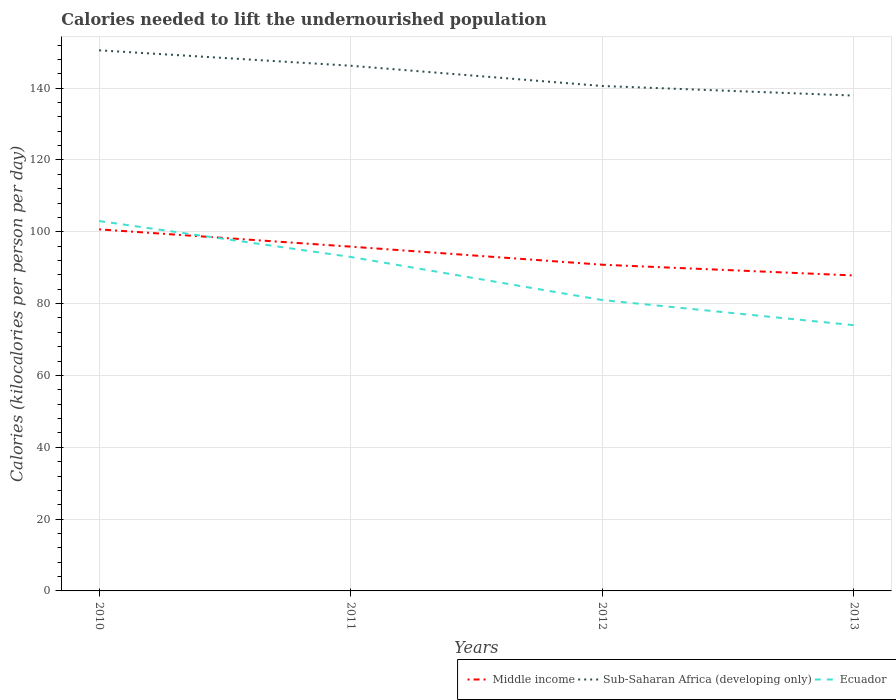How many different coloured lines are there?
Provide a succinct answer. 3. Across all years, what is the maximum total calories needed to lift the undernourished population in Middle income?
Offer a very short reply. 87.84. In which year was the total calories needed to lift the undernourished population in Sub-Saharan Africa (developing only) maximum?
Ensure brevity in your answer.  2013. What is the total total calories needed to lift the undernourished population in Sub-Saharan Africa (developing only) in the graph?
Make the answer very short. 12.6. What is the difference between the highest and the second highest total calories needed to lift the undernourished population in Ecuador?
Your answer should be compact. 29. How many lines are there?
Ensure brevity in your answer.  3. How many years are there in the graph?
Your answer should be compact. 4. Does the graph contain any zero values?
Make the answer very short. No. Does the graph contain grids?
Your answer should be compact. Yes. How many legend labels are there?
Your answer should be very brief. 3. How are the legend labels stacked?
Make the answer very short. Horizontal. What is the title of the graph?
Offer a terse response. Calories needed to lift the undernourished population. Does "Vietnam" appear as one of the legend labels in the graph?
Provide a short and direct response. No. What is the label or title of the X-axis?
Give a very brief answer. Years. What is the label or title of the Y-axis?
Ensure brevity in your answer.  Calories (kilocalories per person per day). What is the Calories (kilocalories per person per day) in Middle income in 2010?
Your answer should be compact. 100.68. What is the Calories (kilocalories per person per day) in Sub-Saharan Africa (developing only) in 2010?
Ensure brevity in your answer.  150.54. What is the Calories (kilocalories per person per day) of Ecuador in 2010?
Make the answer very short. 103. What is the Calories (kilocalories per person per day) in Middle income in 2011?
Keep it short and to the point. 95.87. What is the Calories (kilocalories per person per day) of Sub-Saharan Africa (developing only) in 2011?
Provide a short and direct response. 146.24. What is the Calories (kilocalories per person per day) in Ecuador in 2011?
Give a very brief answer. 93. What is the Calories (kilocalories per person per day) of Middle income in 2012?
Provide a short and direct response. 90.84. What is the Calories (kilocalories per person per day) of Sub-Saharan Africa (developing only) in 2012?
Give a very brief answer. 140.6. What is the Calories (kilocalories per person per day) in Ecuador in 2012?
Offer a very short reply. 81. What is the Calories (kilocalories per person per day) in Middle income in 2013?
Your answer should be very brief. 87.84. What is the Calories (kilocalories per person per day) of Sub-Saharan Africa (developing only) in 2013?
Make the answer very short. 137.94. What is the Calories (kilocalories per person per day) in Ecuador in 2013?
Your response must be concise. 74. Across all years, what is the maximum Calories (kilocalories per person per day) in Middle income?
Ensure brevity in your answer.  100.68. Across all years, what is the maximum Calories (kilocalories per person per day) of Sub-Saharan Africa (developing only)?
Give a very brief answer. 150.54. Across all years, what is the maximum Calories (kilocalories per person per day) in Ecuador?
Ensure brevity in your answer.  103. Across all years, what is the minimum Calories (kilocalories per person per day) in Middle income?
Ensure brevity in your answer.  87.84. Across all years, what is the minimum Calories (kilocalories per person per day) of Sub-Saharan Africa (developing only)?
Make the answer very short. 137.94. What is the total Calories (kilocalories per person per day) of Middle income in the graph?
Provide a short and direct response. 375.23. What is the total Calories (kilocalories per person per day) of Sub-Saharan Africa (developing only) in the graph?
Your answer should be very brief. 575.31. What is the total Calories (kilocalories per person per day) in Ecuador in the graph?
Make the answer very short. 351. What is the difference between the Calories (kilocalories per person per day) of Middle income in 2010 and that in 2011?
Offer a very short reply. 4.81. What is the difference between the Calories (kilocalories per person per day) of Sub-Saharan Africa (developing only) in 2010 and that in 2011?
Offer a very short reply. 4.3. What is the difference between the Calories (kilocalories per person per day) in Ecuador in 2010 and that in 2011?
Provide a short and direct response. 10. What is the difference between the Calories (kilocalories per person per day) of Middle income in 2010 and that in 2012?
Your response must be concise. 9.84. What is the difference between the Calories (kilocalories per person per day) of Sub-Saharan Africa (developing only) in 2010 and that in 2012?
Your answer should be very brief. 9.93. What is the difference between the Calories (kilocalories per person per day) in Middle income in 2010 and that in 2013?
Your answer should be compact. 12.83. What is the difference between the Calories (kilocalories per person per day) in Sub-Saharan Africa (developing only) in 2010 and that in 2013?
Offer a very short reply. 12.6. What is the difference between the Calories (kilocalories per person per day) in Middle income in 2011 and that in 2012?
Provide a short and direct response. 5.03. What is the difference between the Calories (kilocalories per person per day) in Sub-Saharan Africa (developing only) in 2011 and that in 2012?
Offer a very short reply. 5.64. What is the difference between the Calories (kilocalories per person per day) in Ecuador in 2011 and that in 2012?
Ensure brevity in your answer.  12. What is the difference between the Calories (kilocalories per person per day) of Middle income in 2011 and that in 2013?
Your response must be concise. 8.02. What is the difference between the Calories (kilocalories per person per day) in Sub-Saharan Africa (developing only) in 2011 and that in 2013?
Your response must be concise. 8.31. What is the difference between the Calories (kilocalories per person per day) of Middle income in 2012 and that in 2013?
Ensure brevity in your answer.  2.99. What is the difference between the Calories (kilocalories per person per day) in Sub-Saharan Africa (developing only) in 2012 and that in 2013?
Provide a short and direct response. 2.67. What is the difference between the Calories (kilocalories per person per day) of Ecuador in 2012 and that in 2013?
Ensure brevity in your answer.  7. What is the difference between the Calories (kilocalories per person per day) in Middle income in 2010 and the Calories (kilocalories per person per day) in Sub-Saharan Africa (developing only) in 2011?
Provide a short and direct response. -45.56. What is the difference between the Calories (kilocalories per person per day) of Middle income in 2010 and the Calories (kilocalories per person per day) of Ecuador in 2011?
Give a very brief answer. 7.68. What is the difference between the Calories (kilocalories per person per day) of Sub-Saharan Africa (developing only) in 2010 and the Calories (kilocalories per person per day) of Ecuador in 2011?
Keep it short and to the point. 57.54. What is the difference between the Calories (kilocalories per person per day) in Middle income in 2010 and the Calories (kilocalories per person per day) in Sub-Saharan Africa (developing only) in 2012?
Ensure brevity in your answer.  -39.92. What is the difference between the Calories (kilocalories per person per day) of Middle income in 2010 and the Calories (kilocalories per person per day) of Ecuador in 2012?
Provide a succinct answer. 19.68. What is the difference between the Calories (kilocalories per person per day) in Sub-Saharan Africa (developing only) in 2010 and the Calories (kilocalories per person per day) in Ecuador in 2012?
Offer a terse response. 69.54. What is the difference between the Calories (kilocalories per person per day) in Middle income in 2010 and the Calories (kilocalories per person per day) in Sub-Saharan Africa (developing only) in 2013?
Your answer should be very brief. -37.26. What is the difference between the Calories (kilocalories per person per day) of Middle income in 2010 and the Calories (kilocalories per person per day) of Ecuador in 2013?
Keep it short and to the point. 26.68. What is the difference between the Calories (kilocalories per person per day) of Sub-Saharan Africa (developing only) in 2010 and the Calories (kilocalories per person per day) of Ecuador in 2013?
Ensure brevity in your answer.  76.54. What is the difference between the Calories (kilocalories per person per day) of Middle income in 2011 and the Calories (kilocalories per person per day) of Sub-Saharan Africa (developing only) in 2012?
Your answer should be compact. -44.73. What is the difference between the Calories (kilocalories per person per day) in Middle income in 2011 and the Calories (kilocalories per person per day) in Ecuador in 2012?
Your answer should be very brief. 14.87. What is the difference between the Calories (kilocalories per person per day) in Sub-Saharan Africa (developing only) in 2011 and the Calories (kilocalories per person per day) in Ecuador in 2012?
Your answer should be very brief. 65.24. What is the difference between the Calories (kilocalories per person per day) of Middle income in 2011 and the Calories (kilocalories per person per day) of Sub-Saharan Africa (developing only) in 2013?
Offer a very short reply. -42.07. What is the difference between the Calories (kilocalories per person per day) in Middle income in 2011 and the Calories (kilocalories per person per day) in Ecuador in 2013?
Make the answer very short. 21.87. What is the difference between the Calories (kilocalories per person per day) in Sub-Saharan Africa (developing only) in 2011 and the Calories (kilocalories per person per day) in Ecuador in 2013?
Ensure brevity in your answer.  72.24. What is the difference between the Calories (kilocalories per person per day) in Middle income in 2012 and the Calories (kilocalories per person per day) in Sub-Saharan Africa (developing only) in 2013?
Your response must be concise. -47.1. What is the difference between the Calories (kilocalories per person per day) in Middle income in 2012 and the Calories (kilocalories per person per day) in Ecuador in 2013?
Ensure brevity in your answer.  16.84. What is the difference between the Calories (kilocalories per person per day) in Sub-Saharan Africa (developing only) in 2012 and the Calories (kilocalories per person per day) in Ecuador in 2013?
Keep it short and to the point. 66.6. What is the average Calories (kilocalories per person per day) in Middle income per year?
Keep it short and to the point. 93.81. What is the average Calories (kilocalories per person per day) of Sub-Saharan Africa (developing only) per year?
Make the answer very short. 143.83. What is the average Calories (kilocalories per person per day) in Ecuador per year?
Give a very brief answer. 87.75. In the year 2010, what is the difference between the Calories (kilocalories per person per day) of Middle income and Calories (kilocalories per person per day) of Sub-Saharan Africa (developing only)?
Give a very brief answer. -49.86. In the year 2010, what is the difference between the Calories (kilocalories per person per day) of Middle income and Calories (kilocalories per person per day) of Ecuador?
Ensure brevity in your answer.  -2.32. In the year 2010, what is the difference between the Calories (kilocalories per person per day) of Sub-Saharan Africa (developing only) and Calories (kilocalories per person per day) of Ecuador?
Your answer should be very brief. 47.54. In the year 2011, what is the difference between the Calories (kilocalories per person per day) of Middle income and Calories (kilocalories per person per day) of Sub-Saharan Africa (developing only)?
Offer a terse response. -50.37. In the year 2011, what is the difference between the Calories (kilocalories per person per day) of Middle income and Calories (kilocalories per person per day) of Ecuador?
Your answer should be compact. 2.87. In the year 2011, what is the difference between the Calories (kilocalories per person per day) of Sub-Saharan Africa (developing only) and Calories (kilocalories per person per day) of Ecuador?
Provide a succinct answer. 53.24. In the year 2012, what is the difference between the Calories (kilocalories per person per day) of Middle income and Calories (kilocalories per person per day) of Sub-Saharan Africa (developing only)?
Provide a succinct answer. -49.77. In the year 2012, what is the difference between the Calories (kilocalories per person per day) of Middle income and Calories (kilocalories per person per day) of Ecuador?
Ensure brevity in your answer.  9.84. In the year 2012, what is the difference between the Calories (kilocalories per person per day) of Sub-Saharan Africa (developing only) and Calories (kilocalories per person per day) of Ecuador?
Keep it short and to the point. 59.6. In the year 2013, what is the difference between the Calories (kilocalories per person per day) in Middle income and Calories (kilocalories per person per day) in Sub-Saharan Africa (developing only)?
Your answer should be very brief. -50.09. In the year 2013, what is the difference between the Calories (kilocalories per person per day) of Middle income and Calories (kilocalories per person per day) of Ecuador?
Keep it short and to the point. 13.84. In the year 2013, what is the difference between the Calories (kilocalories per person per day) in Sub-Saharan Africa (developing only) and Calories (kilocalories per person per day) in Ecuador?
Provide a short and direct response. 63.94. What is the ratio of the Calories (kilocalories per person per day) in Middle income in 2010 to that in 2011?
Your answer should be very brief. 1.05. What is the ratio of the Calories (kilocalories per person per day) of Sub-Saharan Africa (developing only) in 2010 to that in 2011?
Give a very brief answer. 1.03. What is the ratio of the Calories (kilocalories per person per day) in Ecuador in 2010 to that in 2011?
Your answer should be very brief. 1.11. What is the ratio of the Calories (kilocalories per person per day) of Middle income in 2010 to that in 2012?
Offer a very short reply. 1.11. What is the ratio of the Calories (kilocalories per person per day) in Sub-Saharan Africa (developing only) in 2010 to that in 2012?
Offer a very short reply. 1.07. What is the ratio of the Calories (kilocalories per person per day) in Ecuador in 2010 to that in 2012?
Ensure brevity in your answer.  1.27. What is the ratio of the Calories (kilocalories per person per day) in Middle income in 2010 to that in 2013?
Provide a succinct answer. 1.15. What is the ratio of the Calories (kilocalories per person per day) in Sub-Saharan Africa (developing only) in 2010 to that in 2013?
Keep it short and to the point. 1.09. What is the ratio of the Calories (kilocalories per person per day) of Ecuador in 2010 to that in 2013?
Give a very brief answer. 1.39. What is the ratio of the Calories (kilocalories per person per day) in Middle income in 2011 to that in 2012?
Ensure brevity in your answer.  1.06. What is the ratio of the Calories (kilocalories per person per day) in Sub-Saharan Africa (developing only) in 2011 to that in 2012?
Your answer should be very brief. 1.04. What is the ratio of the Calories (kilocalories per person per day) of Ecuador in 2011 to that in 2012?
Ensure brevity in your answer.  1.15. What is the ratio of the Calories (kilocalories per person per day) in Middle income in 2011 to that in 2013?
Your answer should be very brief. 1.09. What is the ratio of the Calories (kilocalories per person per day) of Sub-Saharan Africa (developing only) in 2011 to that in 2013?
Your answer should be compact. 1.06. What is the ratio of the Calories (kilocalories per person per day) in Ecuador in 2011 to that in 2013?
Your response must be concise. 1.26. What is the ratio of the Calories (kilocalories per person per day) in Middle income in 2012 to that in 2013?
Make the answer very short. 1.03. What is the ratio of the Calories (kilocalories per person per day) of Sub-Saharan Africa (developing only) in 2012 to that in 2013?
Make the answer very short. 1.02. What is the ratio of the Calories (kilocalories per person per day) of Ecuador in 2012 to that in 2013?
Provide a short and direct response. 1.09. What is the difference between the highest and the second highest Calories (kilocalories per person per day) of Middle income?
Give a very brief answer. 4.81. What is the difference between the highest and the second highest Calories (kilocalories per person per day) of Sub-Saharan Africa (developing only)?
Offer a very short reply. 4.3. What is the difference between the highest and the second highest Calories (kilocalories per person per day) in Ecuador?
Provide a succinct answer. 10. What is the difference between the highest and the lowest Calories (kilocalories per person per day) of Middle income?
Keep it short and to the point. 12.83. What is the difference between the highest and the lowest Calories (kilocalories per person per day) of Sub-Saharan Africa (developing only)?
Provide a succinct answer. 12.6. 